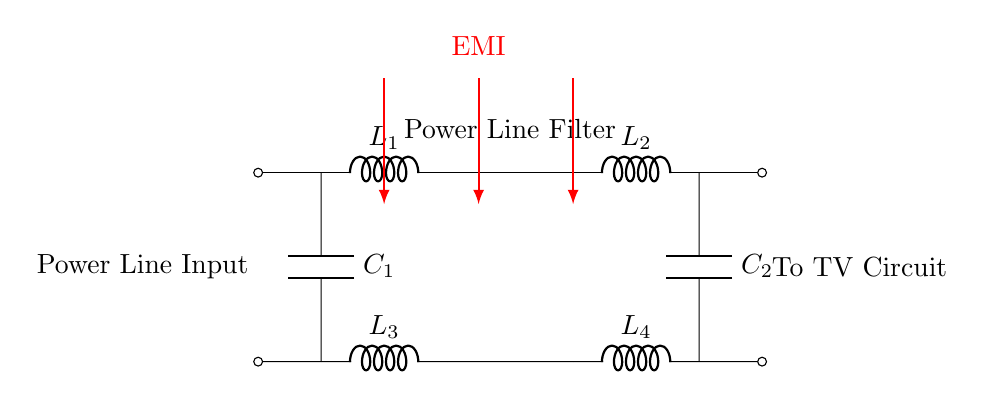What is the main purpose of this circuit? The main purpose of this circuit is to filter out electromagnetic interference from the power line before the electrical power reaches the television set. This is indicated by the labeling "Power Line Filter" and the arrows showing EMI being reduced.
Answer: Power Line Filter How many inductors are present in the circuit? There are four inductors labeled as L1, L2, L3, and L4. Each component is drawn in the circuit and labeled distinctly, which provides the count directly from visual observation.
Answer: Four What components are used to reduce EMI in this circuit? Two capacitors labeled C1 and C2 are used, as they are connected in parallel with the inductors L1 and L4, respectively. The circuit's design clearly shows how these capacitors interact with the inductors to minimize EMI.
Answer: Capacitors What kind of connection is between the inductors and capacitors? The connection is a parallel connection, as indicated by the placement of the capacitors alongside the inductors, allowing for the flow of current through multiple paths concurrently.
Answer: Parallel Which components are likely to experience electromagnetic interference? The inductors L1 and L2 are likely to experience EMI as they are located on the power line input and are directly involved in filtering, which is indicated by the arrows signaling the EMI path.
Answer: Inductors What effect does the configuration of L3 and L4 have on the circuit? The configuration of L3 and L4 helps in filtering the ground path as additional inductors that can counteract EMI, which is essential for maintaining a stable ground reference in the circuit.
Answer: Ground filtering In which direction does the EMI flow in the circuit? EMI flows from the power line input towards the television circuit, as indicated by the red arrows in the diagram, showing the path of interference that the filter aims to reduce.
Answer: Towards TV Circuit 